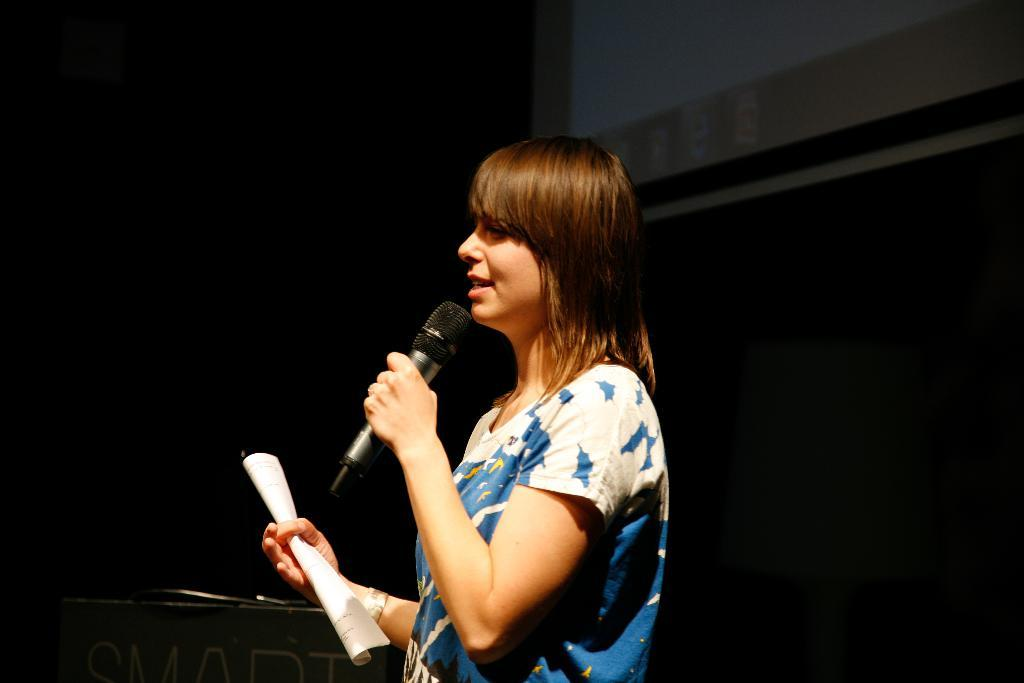What is the main subject of the image? There is a person in the image. What is the person doing in the image? The person is standing facing her left and holding a paper in one hand and a microphone in the other hand. What is the person wearing in the image? The person is wearing a blue and white colored t-shirt. What type of linen is being used to cover the table in the image? There is no table or linen present in the image; it features a person holding a paper and a microphone. What type of test is the person taking in the image? There is no test being taken in the image; the person is holding a paper and a microphone, but their activity is not specified as a test. 